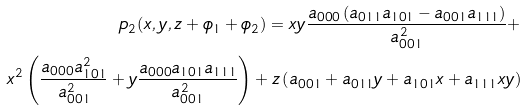<formula> <loc_0><loc_0><loc_500><loc_500>p _ { 2 } ( x , y , z + \phi _ { 1 } + \phi _ { 2 } ) = x y \frac { a _ { 0 0 0 } \left ( a _ { 0 1 1 } a _ { 1 0 1 } - a _ { 0 0 1 } a _ { 1 1 1 } \right ) } { a _ { 0 0 1 } ^ { 2 } } + \\ x ^ { 2 } \left ( \frac { a _ { 0 0 0 } a _ { 1 0 1 } ^ { 2 } } { a _ { 0 0 1 } ^ { 2 } } + y \frac { a _ { 0 0 0 } a _ { 1 0 1 } a _ { 1 1 1 } } { a _ { 0 0 1 } ^ { 2 } } \right ) + z \left ( a _ { 0 0 1 } + a _ { 0 1 1 } y + a _ { 1 0 1 } x + a _ { 1 1 1 } x y \right )</formula> 